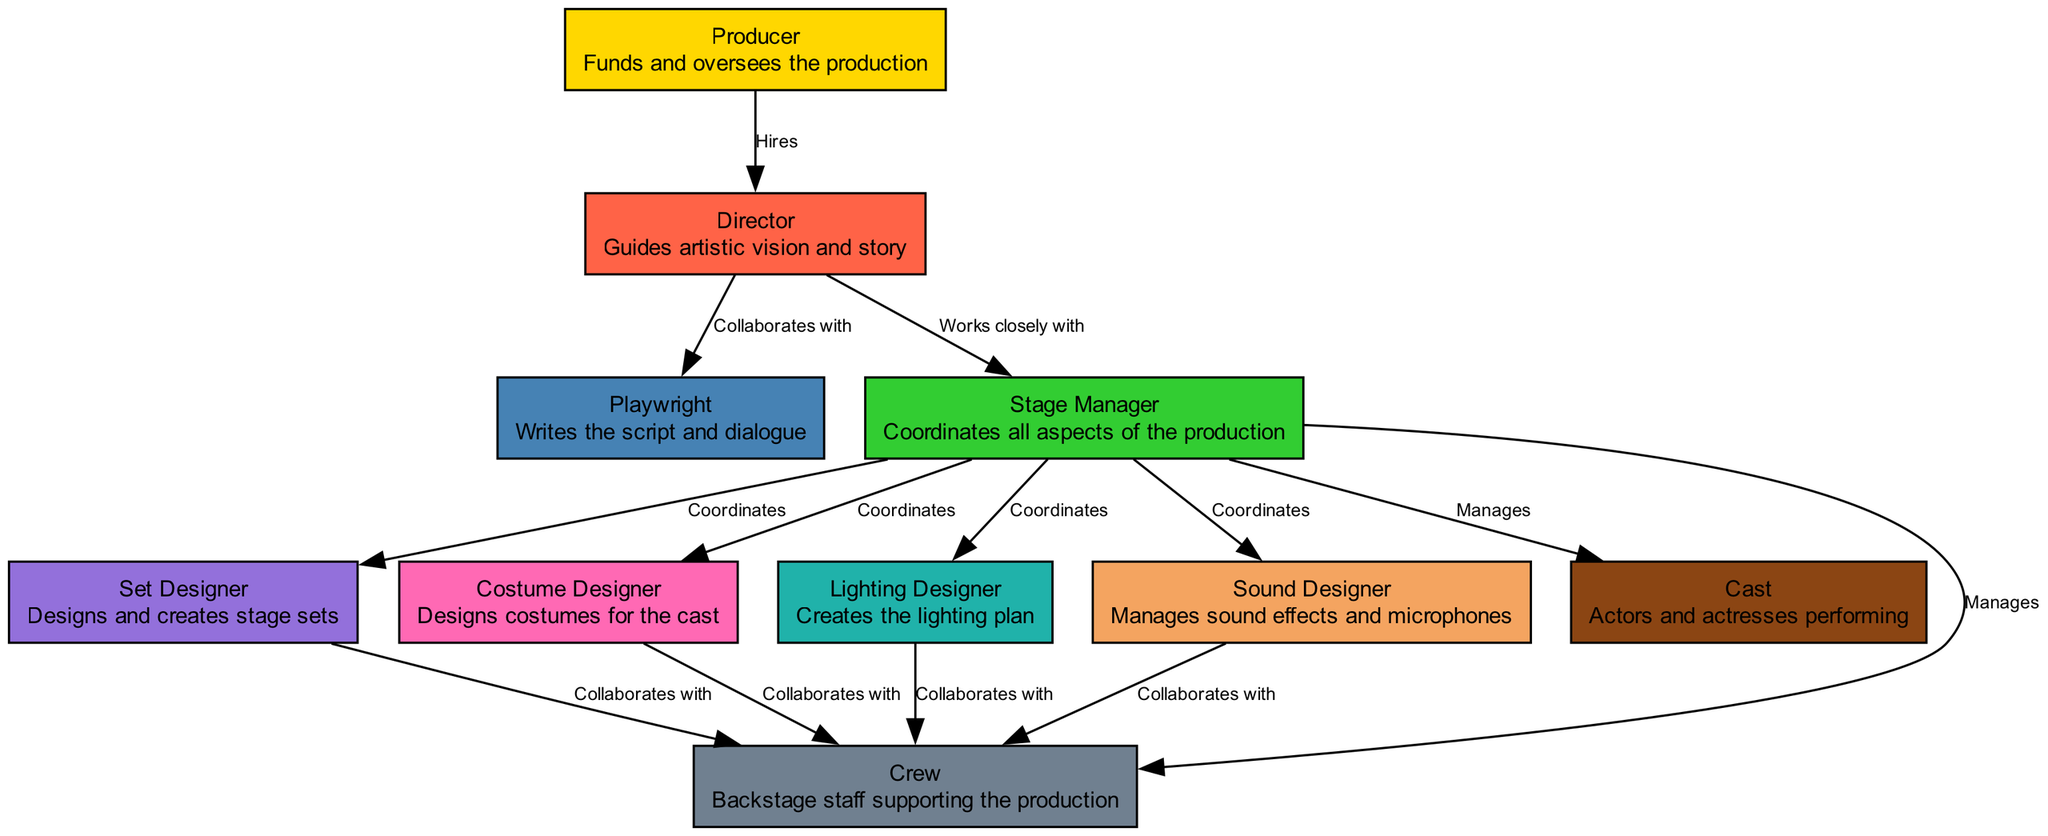What role oversees the production funds? The diagram identifies the "Producer" as the role that funds and oversees the production, as shown in the node description.
Answer: Producer How many total roles are depicted in the diagram? The diagram lists ten distinct roles related to theater production, each represented as a separate node.
Answer: 10 Who collaborates with the Director? The edges indicate that the Director collaborates with the Playwright and works closely with the Stage Manager, as depicted by the connecting lines and labels.
Answer: Playwright; Stage Manager What role is responsible for managing sound effects? According to the diagram, the "Sound Designer" manages sound effects and microphones, which is specifically stated in the node description.
Answer: Sound Designer Which position coordinates all aspects of the production? The diagram explicitly notes that the "Stage Manager" is tasked with coordinating all aspects of the production, as described in its node.
Answer: Stage Manager Which node collaborates with both Set Designer and Costume Designer? The diagram shows that the "Crew" collaborates with both the Set Designer and the Costume Designer, as indicated by the edges connecting these nodes.
Answer: Crew How many edges indicate collaboration within the diagram? The diagram includes four edges labeled as "Collaborates with," connecting the Crew with Set Designer, Costume Designer, Lighting Designer, and Sound Designer, making a total of four collaboration edges.
Answer: 4 Which role does the Stage Manager manage directly? The diagram shows that the Stage Manager manages both the Cast and the Crew, indicated by the edges connecting the Stage Manager to these nodes.
Answer: Cast; Crew What is the main responsibility of the Playwright? As described in the diagram, the Playwright's main responsibility is to write the script and dialogue, outlined in the node's description.
Answer: Writes the script and dialogue Who hires the Director? The diagram indicates through an edge that the Producer is the one who hires the Director, according to the labeling of the connecting line.
Answer: Producer 